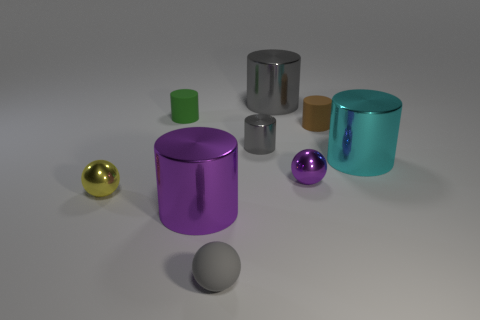Subtract all tiny metallic cylinders. How many cylinders are left? 5 Subtract all brown cylinders. How many cylinders are left? 5 Subtract all brown cylinders. Subtract all cyan cubes. How many cylinders are left? 5 Add 1 small spheres. How many objects exist? 10 Subtract all cylinders. How many objects are left? 3 Subtract 0 cyan cubes. How many objects are left? 9 Subtract all tiny rubber things. Subtract all tiny gray rubber balls. How many objects are left? 5 Add 1 big cylinders. How many big cylinders are left? 4 Add 7 tiny purple cylinders. How many tiny purple cylinders exist? 7 